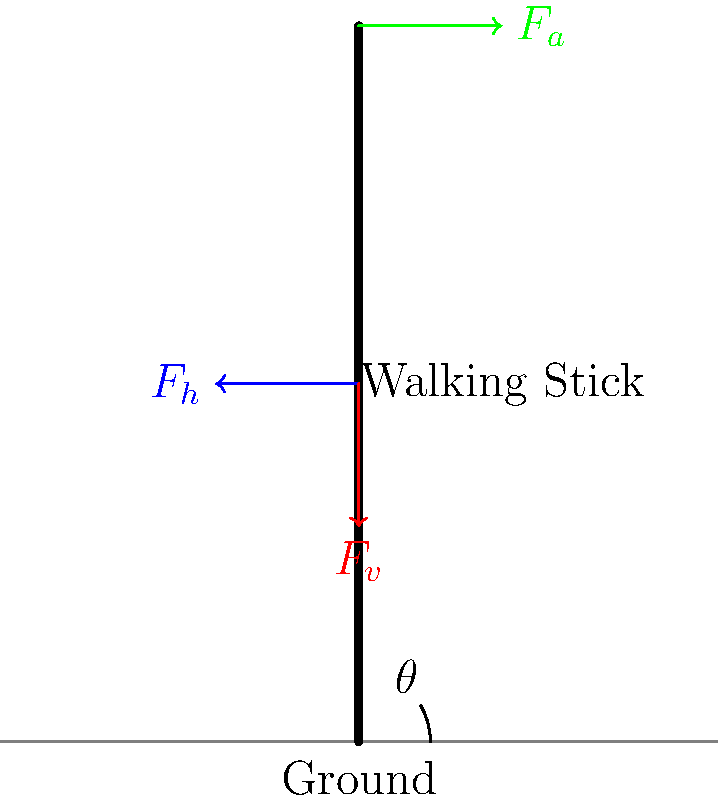A unique walking stick is designed with a special grip that allows the user to apply a horizontal force $F_h$ in addition to the vertical force $F_v$. If the stick makes an angle $\theta$ with the ground and experiences an axial force $F_a$ along its length, express $F_a$ in terms of $F_h$, $F_v$, and $\theta$. To solve this problem, we'll follow these steps:

1) First, we need to understand that the axial force $F_a$ is the resultant force along the length of the walking stick.

2) We can decompose both $F_h$ and $F_v$ into components parallel to the walking stick:

   - The component of $F_h$ parallel to the stick is $F_h \cos \theta$
   - The component of $F_v$ parallel to the stick is $F_v \sin \theta$

3) The axial force $F_a$ is the sum of these components:

   $F_a = F_h \cos \theta + F_v \sin \theta$

4) This equation expresses $F_a$ in terms of $F_h$, $F_v$, and $\theta$ as required.

Note: This analysis assumes that $F_h$ and $F_v$ are applied at the same point on the stick. If they were applied at different points, we would need to consider moments as well.
Answer: $F_a = F_h \cos \theta + F_v \sin \theta$ 